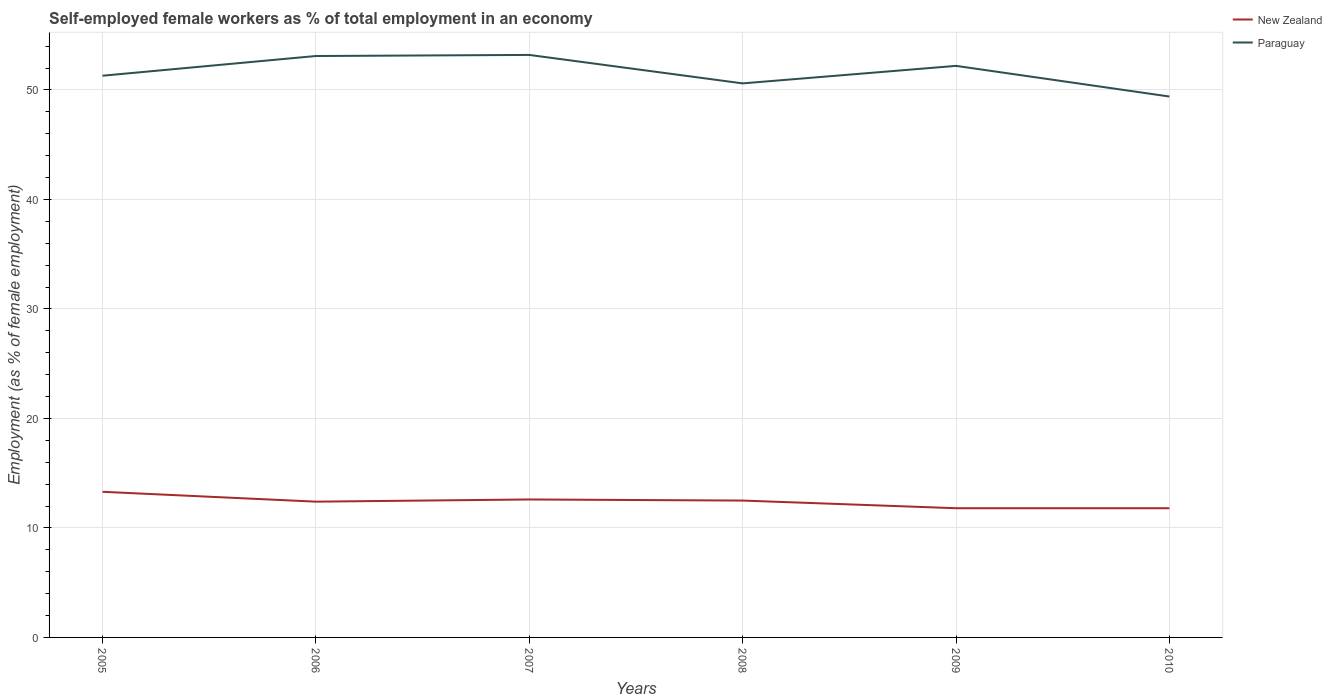Across all years, what is the maximum percentage of self-employed female workers in Paraguay?
Make the answer very short. 49.4. What is the total percentage of self-employed female workers in New Zealand in the graph?
Your response must be concise. -0.2. What is the difference between the highest and the second highest percentage of self-employed female workers in Paraguay?
Ensure brevity in your answer.  3.8. Is the percentage of self-employed female workers in Paraguay strictly greater than the percentage of self-employed female workers in New Zealand over the years?
Keep it short and to the point. No. How many lines are there?
Keep it short and to the point. 2. How many years are there in the graph?
Offer a very short reply. 6. Are the values on the major ticks of Y-axis written in scientific E-notation?
Provide a succinct answer. No. Does the graph contain any zero values?
Your response must be concise. No. Where does the legend appear in the graph?
Provide a succinct answer. Top right. How many legend labels are there?
Keep it short and to the point. 2. What is the title of the graph?
Your answer should be compact. Self-employed female workers as % of total employment in an economy. Does "Comoros" appear as one of the legend labels in the graph?
Give a very brief answer. No. What is the label or title of the X-axis?
Ensure brevity in your answer.  Years. What is the label or title of the Y-axis?
Your response must be concise. Employment (as % of female employment). What is the Employment (as % of female employment) of New Zealand in 2005?
Your response must be concise. 13.3. What is the Employment (as % of female employment) of Paraguay in 2005?
Give a very brief answer. 51.3. What is the Employment (as % of female employment) in New Zealand in 2006?
Provide a short and direct response. 12.4. What is the Employment (as % of female employment) of Paraguay in 2006?
Provide a short and direct response. 53.1. What is the Employment (as % of female employment) in New Zealand in 2007?
Ensure brevity in your answer.  12.6. What is the Employment (as % of female employment) of Paraguay in 2007?
Provide a short and direct response. 53.2. What is the Employment (as % of female employment) of Paraguay in 2008?
Your answer should be compact. 50.6. What is the Employment (as % of female employment) in New Zealand in 2009?
Offer a very short reply. 11.8. What is the Employment (as % of female employment) in Paraguay in 2009?
Your answer should be compact. 52.2. What is the Employment (as % of female employment) in New Zealand in 2010?
Make the answer very short. 11.8. What is the Employment (as % of female employment) of Paraguay in 2010?
Your response must be concise. 49.4. Across all years, what is the maximum Employment (as % of female employment) of New Zealand?
Offer a terse response. 13.3. Across all years, what is the maximum Employment (as % of female employment) of Paraguay?
Offer a terse response. 53.2. Across all years, what is the minimum Employment (as % of female employment) in New Zealand?
Offer a very short reply. 11.8. Across all years, what is the minimum Employment (as % of female employment) in Paraguay?
Your answer should be compact. 49.4. What is the total Employment (as % of female employment) of New Zealand in the graph?
Provide a succinct answer. 74.4. What is the total Employment (as % of female employment) of Paraguay in the graph?
Provide a succinct answer. 309.8. What is the difference between the Employment (as % of female employment) in New Zealand in 2005 and that in 2006?
Keep it short and to the point. 0.9. What is the difference between the Employment (as % of female employment) of New Zealand in 2005 and that in 2008?
Give a very brief answer. 0.8. What is the difference between the Employment (as % of female employment) of Paraguay in 2005 and that in 2008?
Your response must be concise. 0.7. What is the difference between the Employment (as % of female employment) of New Zealand in 2005 and that in 2009?
Your answer should be compact. 1.5. What is the difference between the Employment (as % of female employment) in Paraguay in 2005 and that in 2009?
Offer a very short reply. -0.9. What is the difference between the Employment (as % of female employment) in Paraguay in 2005 and that in 2010?
Your answer should be compact. 1.9. What is the difference between the Employment (as % of female employment) in New Zealand in 2006 and that in 2009?
Keep it short and to the point. 0.6. What is the difference between the Employment (as % of female employment) in New Zealand in 2006 and that in 2010?
Provide a succinct answer. 0.6. What is the difference between the Employment (as % of female employment) of New Zealand in 2007 and that in 2008?
Offer a terse response. 0.1. What is the difference between the Employment (as % of female employment) in New Zealand in 2007 and that in 2009?
Offer a very short reply. 0.8. What is the difference between the Employment (as % of female employment) of Paraguay in 2007 and that in 2009?
Your answer should be very brief. 1. What is the difference between the Employment (as % of female employment) in New Zealand in 2007 and that in 2010?
Ensure brevity in your answer.  0.8. What is the difference between the Employment (as % of female employment) of New Zealand in 2008 and that in 2009?
Keep it short and to the point. 0.7. What is the difference between the Employment (as % of female employment) of Paraguay in 2008 and that in 2009?
Provide a succinct answer. -1.6. What is the difference between the Employment (as % of female employment) of New Zealand in 2009 and that in 2010?
Provide a succinct answer. 0. What is the difference between the Employment (as % of female employment) of Paraguay in 2009 and that in 2010?
Offer a terse response. 2.8. What is the difference between the Employment (as % of female employment) in New Zealand in 2005 and the Employment (as % of female employment) in Paraguay in 2006?
Your answer should be compact. -39.8. What is the difference between the Employment (as % of female employment) of New Zealand in 2005 and the Employment (as % of female employment) of Paraguay in 2007?
Ensure brevity in your answer.  -39.9. What is the difference between the Employment (as % of female employment) in New Zealand in 2005 and the Employment (as % of female employment) in Paraguay in 2008?
Provide a succinct answer. -37.3. What is the difference between the Employment (as % of female employment) of New Zealand in 2005 and the Employment (as % of female employment) of Paraguay in 2009?
Offer a terse response. -38.9. What is the difference between the Employment (as % of female employment) of New Zealand in 2005 and the Employment (as % of female employment) of Paraguay in 2010?
Keep it short and to the point. -36.1. What is the difference between the Employment (as % of female employment) of New Zealand in 2006 and the Employment (as % of female employment) of Paraguay in 2007?
Your answer should be very brief. -40.8. What is the difference between the Employment (as % of female employment) of New Zealand in 2006 and the Employment (as % of female employment) of Paraguay in 2008?
Ensure brevity in your answer.  -38.2. What is the difference between the Employment (as % of female employment) of New Zealand in 2006 and the Employment (as % of female employment) of Paraguay in 2009?
Give a very brief answer. -39.8. What is the difference between the Employment (as % of female employment) in New Zealand in 2006 and the Employment (as % of female employment) in Paraguay in 2010?
Keep it short and to the point. -37. What is the difference between the Employment (as % of female employment) in New Zealand in 2007 and the Employment (as % of female employment) in Paraguay in 2008?
Your answer should be compact. -38. What is the difference between the Employment (as % of female employment) of New Zealand in 2007 and the Employment (as % of female employment) of Paraguay in 2009?
Ensure brevity in your answer.  -39.6. What is the difference between the Employment (as % of female employment) in New Zealand in 2007 and the Employment (as % of female employment) in Paraguay in 2010?
Ensure brevity in your answer.  -36.8. What is the difference between the Employment (as % of female employment) of New Zealand in 2008 and the Employment (as % of female employment) of Paraguay in 2009?
Your response must be concise. -39.7. What is the difference between the Employment (as % of female employment) in New Zealand in 2008 and the Employment (as % of female employment) in Paraguay in 2010?
Give a very brief answer. -36.9. What is the difference between the Employment (as % of female employment) in New Zealand in 2009 and the Employment (as % of female employment) in Paraguay in 2010?
Give a very brief answer. -37.6. What is the average Employment (as % of female employment) of New Zealand per year?
Offer a terse response. 12.4. What is the average Employment (as % of female employment) in Paraguay per year?
Your answer should be very brief. 51.63. In the year 2005, what is the difference between the Employment (as % of female employment) in New Zealand and Employment (as % of female employment) in Paraguay?
Give a very brief answer. -38. In the year 2006, what is the difference between the Employment (as % of female employment) of New Zealand and Employment (as % of female employment) of Paraguay?
Your response must be concise. -40.7. In the year 2007, what is the difference between the Employment (as % of female employment) of New Zealand and Employment (as % of female employment) of Paraguay?
Give a very brief answer. -40.6. In the year 2008, what is the difference between the Employment (as % of female employment) in New Zealand and Employment (as % of female employment) in Paraguay?
Offer a terse response. -38.1. In the year 2009, what is the difference between the Employment (as % of female employment) of New Zealand and Employment (as % of female employment) of Paraguay?
Offer a terse response. -40.4. In the year 2010, what is the difference between the Employment (as % of female employment) of New Zealand and Employment (as % of female employment) of Paraguay?
Provide a short and direct response. -37.6. What is the ratio of the Employment (as % of female employment) in New Zealand in 2005 to that in 2006?
Keep it short and to the point. 1.07. What is the ratio of the Employment (as % of female employment) of Paraguay in 2005 to that in 2006?
Ensure brevity in your answer.  0.97. What is the ratio of the Employment (as % of female employment) in New Zealand in 2005 to that in 2007?
Offer a very short reply. 1.06. What is the ratio of the Employment (as % of female employment) in Paraguay in 2005 to that in 2007?
Your answer should be compact. 0.96. What is the ratio of the Employment (as % of female employment) of New Zealand in 2005 to that in 2008?
Give a very brief answer. 1.06. What is the ratio of the Employment (as % of female employment) in Paraguay in 2005 to that in 2008?
Provide a succinct answer. 1.01. What is the ratio of the Employment (as % of female employment) in New Zealand in 2005 to that in 2009?
Ensure brevity in your answer.  1.13. What is the ratio of the Employment (as % of female employment) of Paraguay in 2005 to that in 2009?
Your response must be concise. 0.98. What is the ratio of the Employment (as % of female employment) in New Zealand in 2005 to that in 2010?
Keep it short and to the point. 1.13. What is the ratio of the Employment (as % of female employment) in Paraguay in 2005 to that in 2010?
Offer a very short reply. 1.04. What is the ratio of the Employment (as % of female employment) of New Zealand in 2006 to that in 2007?
Provide a short and direct response. 0.98. What is the ratio of the Employment (as % of female employment) of Paraguay in 2006 to that in 2007?
Your answer should be very brief. 1. What is the ratio of the Employment (as % of female employment) of Paraguay in 2006 to that in 2008?
Keep it short and to the point. 1.05. What is the ratio of the Employment (as % of female employment) in New Zealand in 2006 to that in 2009?
Make the answer very short. 1.05. What is the ratio of the Employment (as % of female employment) of Paraguay in 2006 to that in 2009?
Your answer should be compact. 1.02. What is the ratio of the Employment (as % of female employment) of New Zealand in 2006 to that in 2010?
Make the answer very short. 1.05. What is the ratio of the Employment (as % of female employment) of Paraguay in 2006 to that in 2010?
Ensure brevity in your answer.  1.07. What is the ratio of the Employment (as % of female employment) in New Zealand in 2007 to that in 2008?
Provide a succinct answer. 1.01. What is the ratio of the Employment (as % of female employment) in Paraguay in 2007 to that in 2008?
Your answer should be compact. 1.05. What is the ratio of the Employment (as % of female employment) in New Zealand in 2007 to that in 2009?
Offer a terse response. 1.07. What is the ratio of the Employment (as % of female employment) in Paraguay in 2007 to that in 2009?
Provide a short and direct response. 1.02. What is the ratio of the Employment (as % of female employment) in New Zealand in 2007 to that in 2010?
Make the answer very short. 1.07. What is the ratio of the Employment (as % of female employment) of Paraguay in 2007 to that in 2010?
Your answer should be very brief. 1.08. What is the ratio of the Employment (as % of female employment) of New Zealand in 2008 to that in 2009?
Ensure brevity in your answer.  1.06. What is the ratio of the Employment (as % of female employment) in Paraguay in 2008 to that in 2009?
Offer a terse response. 0.97. What is the ratio of the Employment (as % of female employment) of New Zealand in 2008 to that in 2010?
Give a very brief answer. 1.06. What is the ratio of the Employment (as % of female employment) in Paraguay in 2008 to that in 2010?
Provide a succinct answer. 1.02. What is the ratio of the Employment (as % of female employment) in Paraguay in 2009 to that in 2010?
Your answer should be compact. 1.06. What is the difference between the highest and the second highest Employment (as % of female employment) of Paraguay?
Your answer should be very brief. 0.1. What is the difference between the highest and the lowest Employment (as % of female employment) in New Zealand?
Give a very brief answer. 1.5. 